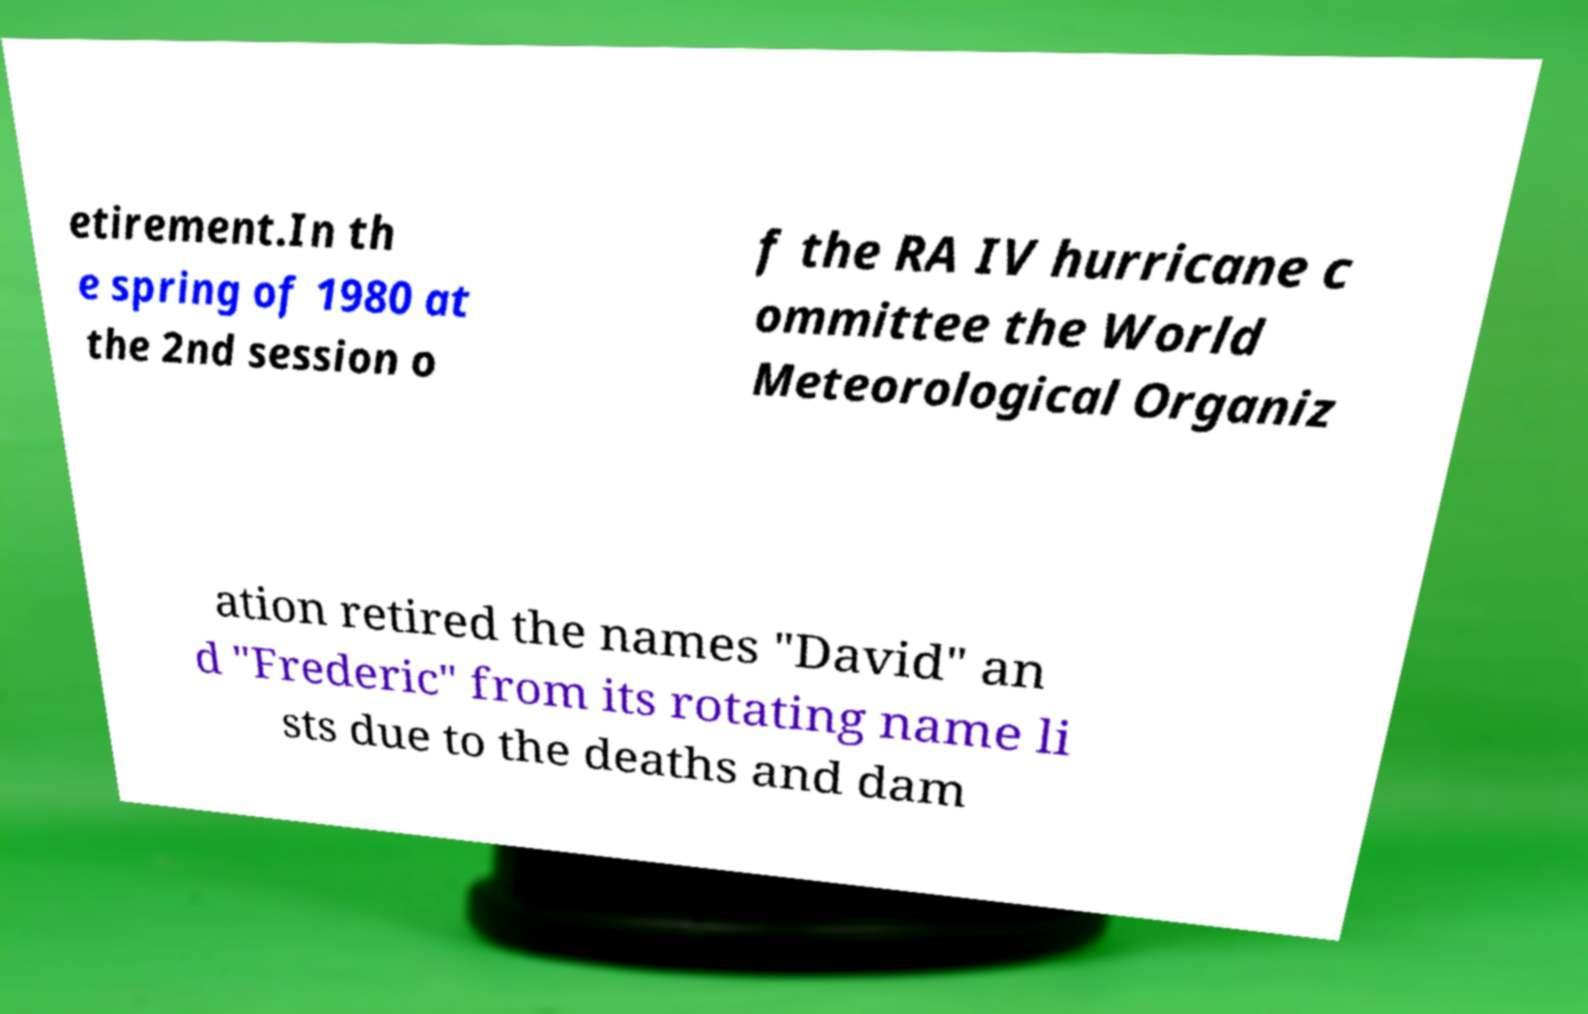For documentation purposes, I need the text within this image transcribed. Could you provide that? etirement.In th e spring of 1980 at the 2nd session o f the RA IV hurricane c ommittee the World Meteorological Organiz ation retired the names "David" an d "Frederic" from its rotating name li sts due to the deaths and dam 